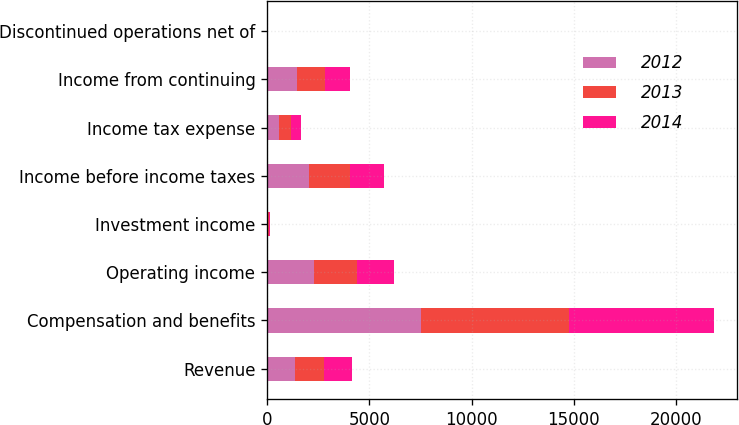<chart> <loc_0><loc_0><loc_500><loc_500><stacked_bar_chart><ecel><fcel>Revenue<fcel>Compensation and benefits<fcel>Operating income<fcel>Investment income<fcel>Income before income taxes<fcel>Income tax expense<fcel>Income from continuing<fcel>Discontinued operations net of<nl><fcel>2012<fcel>1379<fcel>7515<fcel>2301<fcel>37<fcel>2057<fcel>586<fcel>1471<fcel>26<nl><fcel>2013<fcel>1379<fcel>7226<fcel>2077<fcel>69<fcel>1973<fcel>594<fcel>1379<fcel>6<nl><fcel>2014<fcel>1379<fcel>7134<fcel>1829<fcel>24<fcel>1696<fcel>492<fcel>1204<fcel>3<nl></chart> 